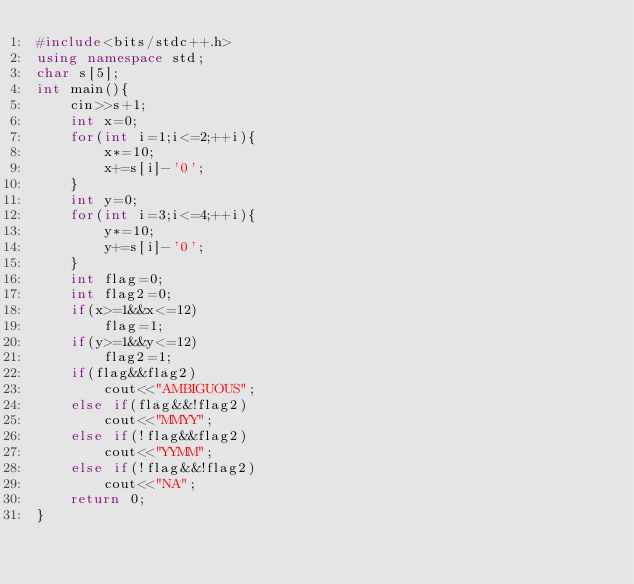<code> <loc_0><loc_0><loc_500><loc_500><_C++_>#include<bits/stdc++.h>
using namespace std;
char s[5];
int main(){
    cin>>s+1;
    int x=0;
    for(int i=1;i<=2;++i){
        x*=10;
        x+=s[i]-'0';
    }
    int y=0;
    for(int i=3;i<=4;++i){
        y*=10;
        y+=s[i]-'0';
    }
    int flag=0;
    int flag2=0;
    if(x>=1&&x<=12)
        flag=1;
    if(y>=1&&y<=12)
        flag2=1;
    if(flag&&flag2)
        cout<<"AMBIGUOUS";
    else if(flag&&!flag2)
        cout<<"MMYY";
    else if(!flag&&flag2)
        cout<<"YYMM";
    else if(!flag&&!flag2)
        cout<<"NA";
    return 0;
}

</code> 